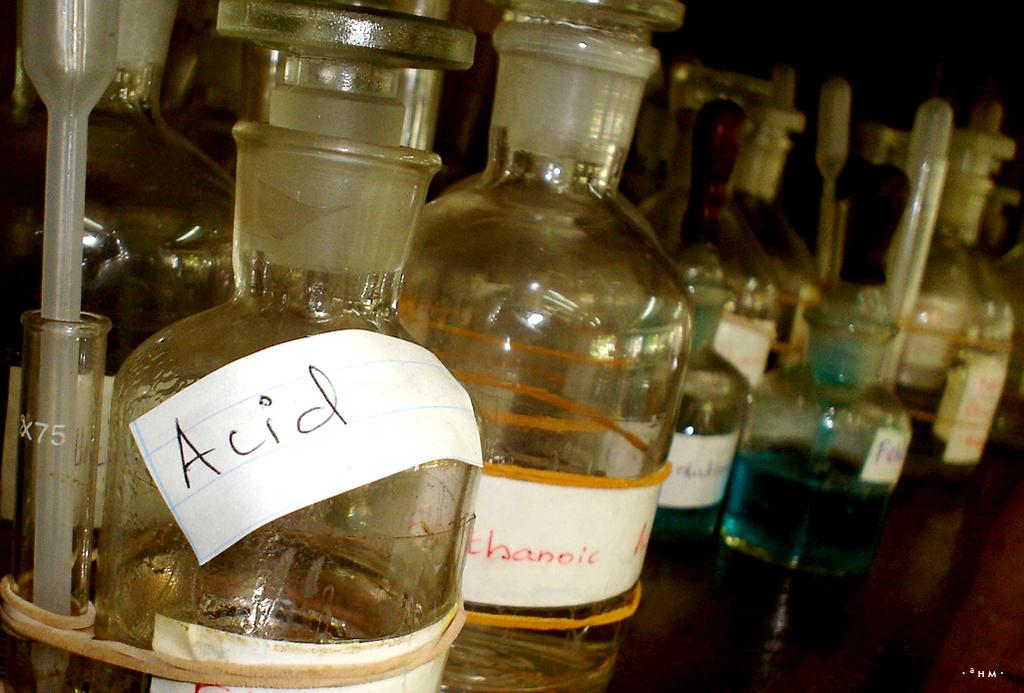<image>
Offer a succinct explanation of the picture presented. A piece of paper with acid written on it has been attached to a glass container. 